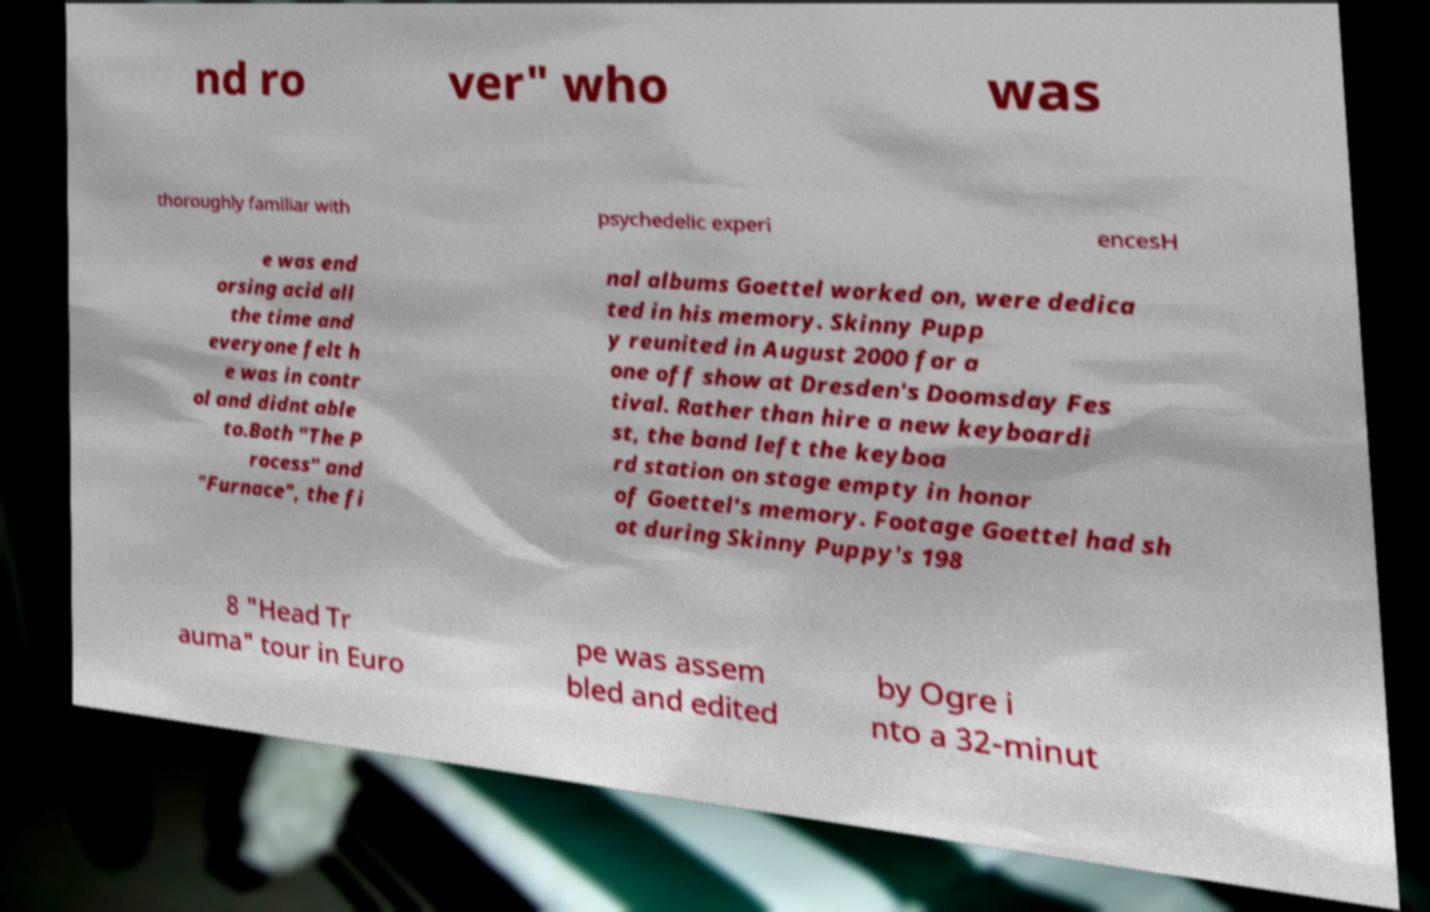Please identify and transcribe the text found in this image. nd ro ver" who was thoroughly familiar with psychedelic experi encesH e was end orsing acid all the time and everyone felt h e was in contr ol and didnt able to.Both "The P rocess" and "Furnace", the fi nal albums Goettel worked on, were dedica ted in his memory. Skinny Pupp y reunited in August 2000 for a one off show at Dresden's Doomsday Fes tival. Rather than hire a new keyboardi st, the band left the keyboa rd station on stage empty in honor of Goettel's memory. Footage Goettel had sh ot during Skinny Puppy's 198 8 "Head Tr auma" tour in Euro pe was assem bled and edited by Ogre i nto a 32-minut 